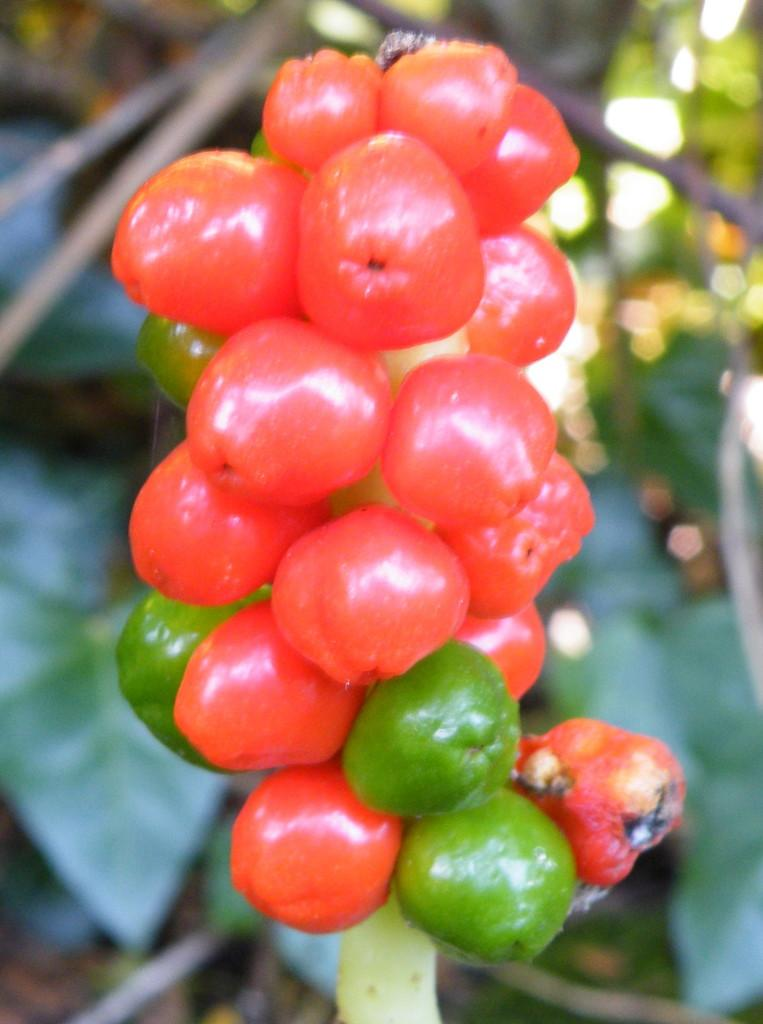What is the focus of the image? The image is zoomed in on red and green color objects in the center. What can be inferred about the objects in the center? The objects appear to be fruits. What else can be seen in the image? There are many other objects visible in the background of the image. How does the credit card help in the growth of the cabbage in the image? There is no credit card or cabbage present in the image. What type of rake is being used to harvest the fruits in the image? There is no rake visible in the image; the fruits are simply shown in the center. 